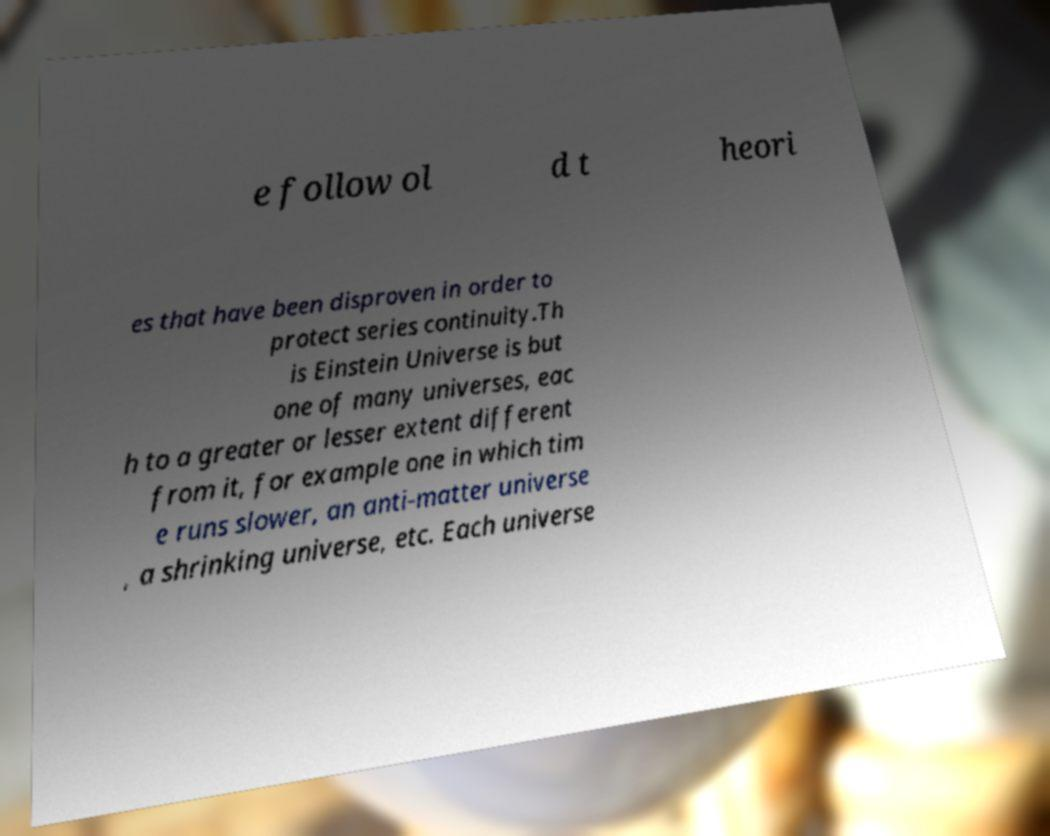Could you assist in decoding the text presented in this image and type it out clearly? e follow ol d t heori es that have been disproven in order to protect series continuity.Th is Einstein Universe is but one of many universes, eac h to a greater or lesser extent different from it, for example one in which tim e runs slower, an anti-matter universe , a shrinking universe, etc. Each universe 